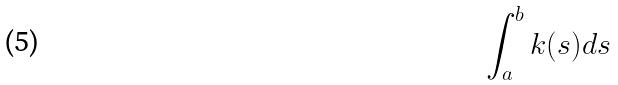Convert formula to latex. <formula><loc_0><loc_0><loc_500><loc_500>\int _ { a } ^ { b } k ( s ) d s</formula> 